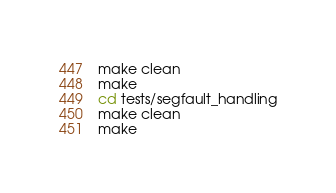<code> <loc_0><loc_0><loc_500><loc_500><_Bash_>make clean
make
cd tests/segfault_handling
make clean
make

</code> 